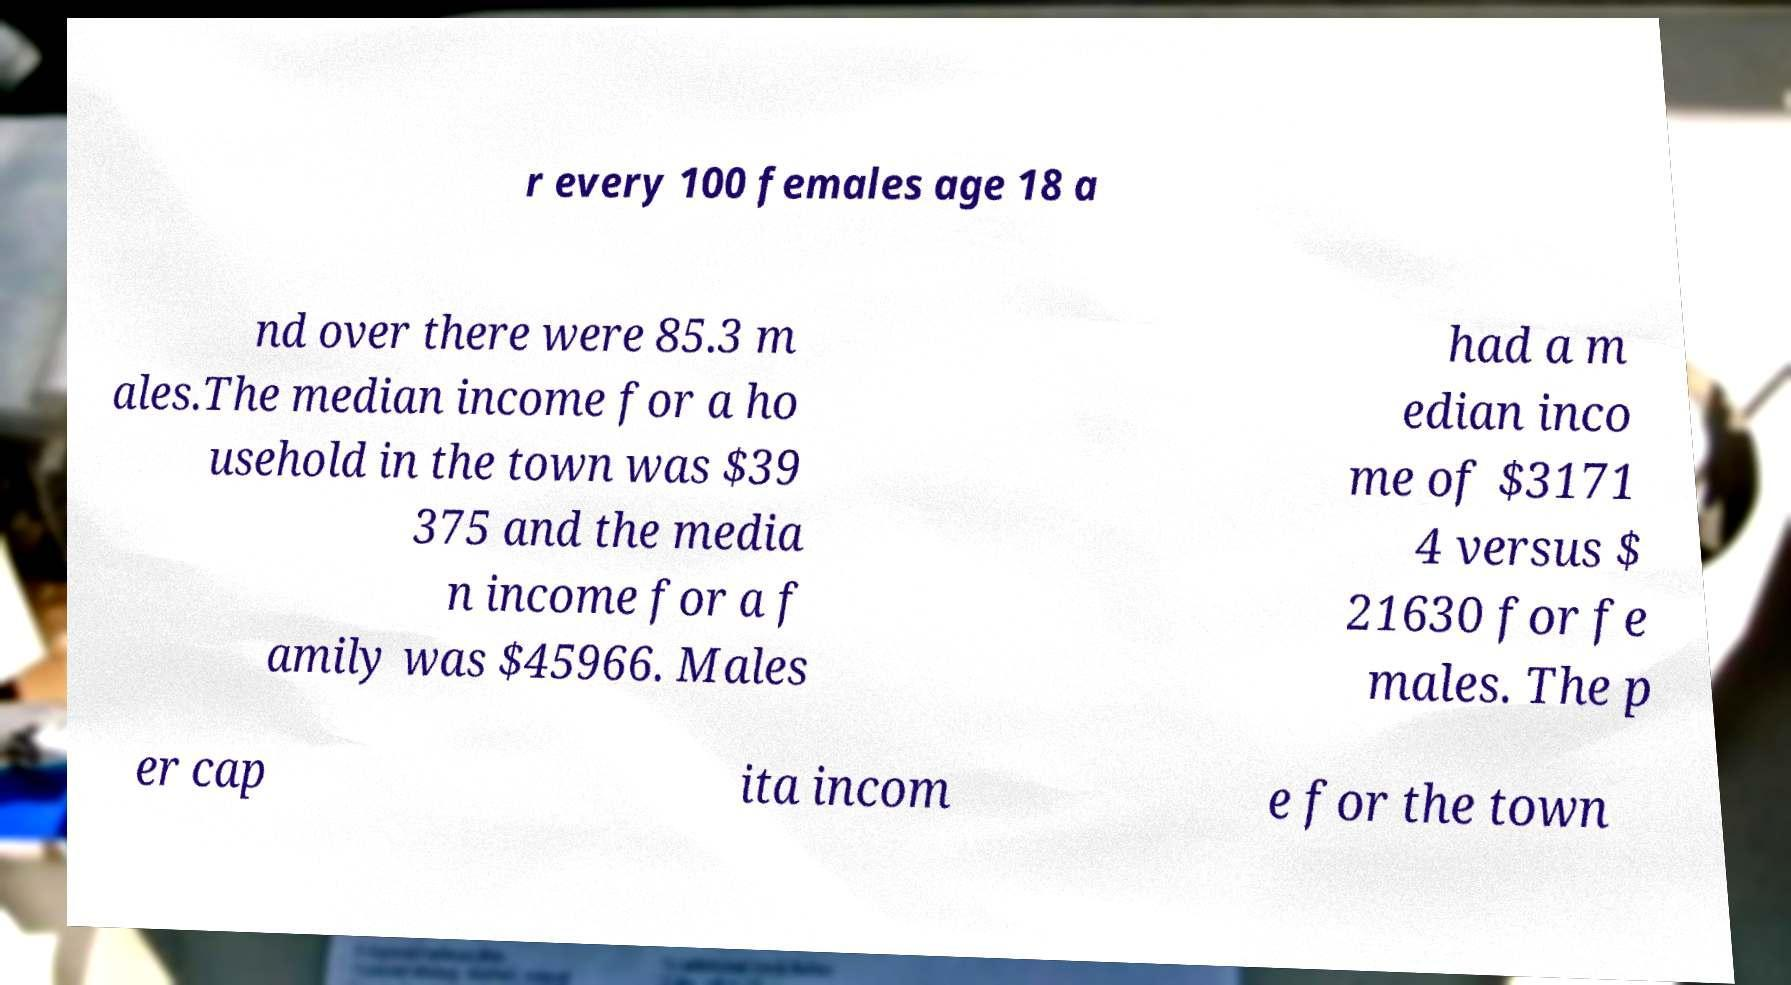Could you assist in decoding the text presented in this image and type it out clearly? r every 100 females age 18 a nd over there were 85.3 m ales.The median income for a ho usehold in the town was $39 375 and the media n income for a f amily was $45966. Males had a m edian inco me of $3171 4 versus $ 21630 for fe males. The p er cap ita incom e for the town 